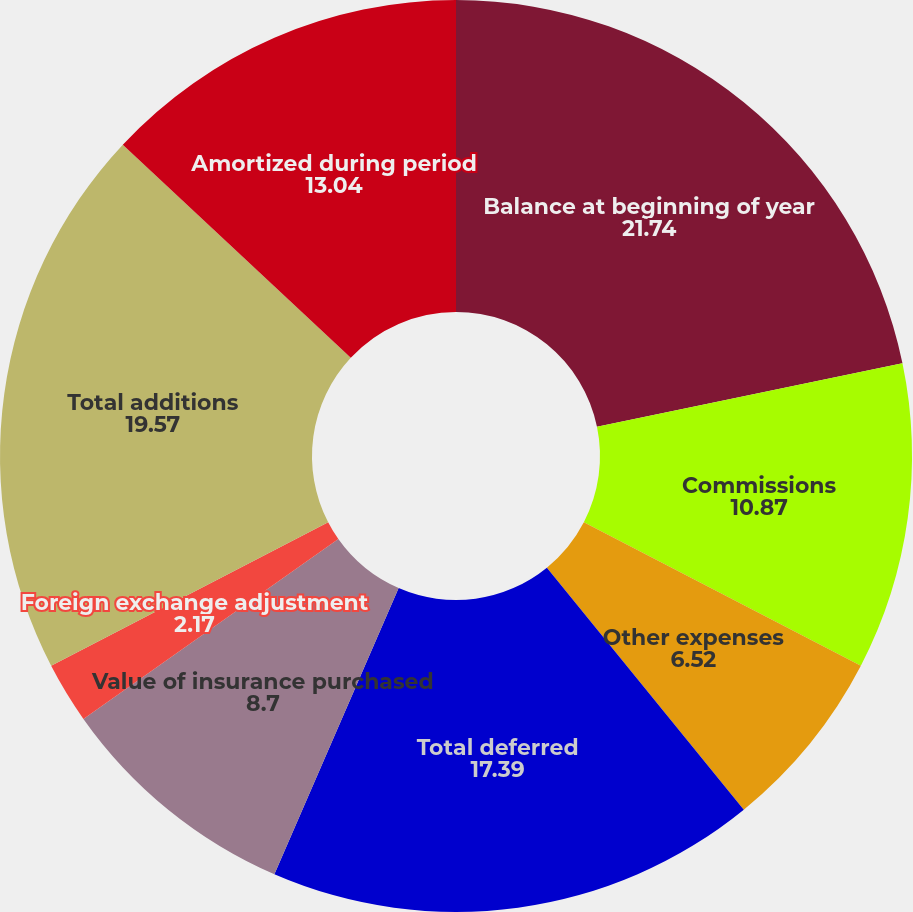Convert chart. <chart><loc_0><loc_0><loc_500><loc_500><pie_chart><fcel>Balance at beginning of year<fcel>Commissions<fcel>Other expenses<fcel>Total deferred<fcel>Value of insurance purchased<fcel>Foreign exchange adjustment<fcel>Adjustment attributable to<fcel>Total additions<fcel>Amortized during period<nl><fcel>21.74%<fcel>10.87%<fcel>6.52%<fcel>17.39%<fcel>8.7%<fcel>2.17%<fcel>0.0%<fcel>19.57%<fcel>13.04%<nl></chart> 